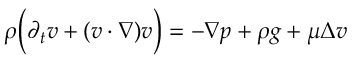Convert formula to latex. <formula><loc_0><loc_0><loc_500><loc_500>\begin{array} { r } { \rho \left ( \partial _ { t } v + ( v \cdot \nabla ) v \right ) = - \nabla p + \rho g + \mu \Delta v } \end{array}</formula> 